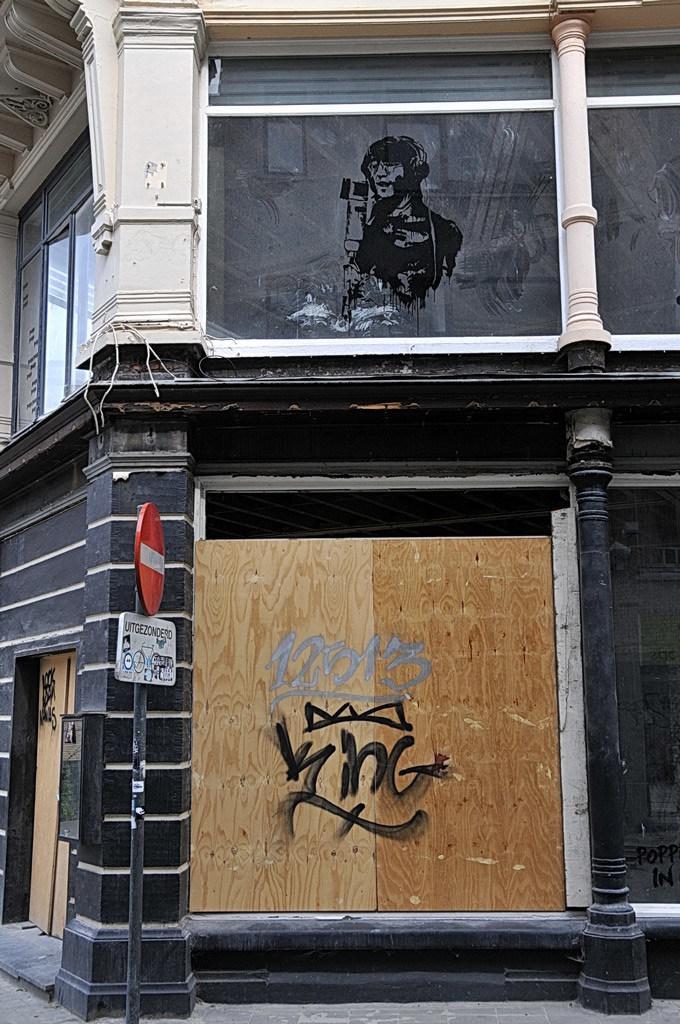Describe this image in one or two sentences. In this image there is a painting. On the wall there are paintings. This is a sign board. 